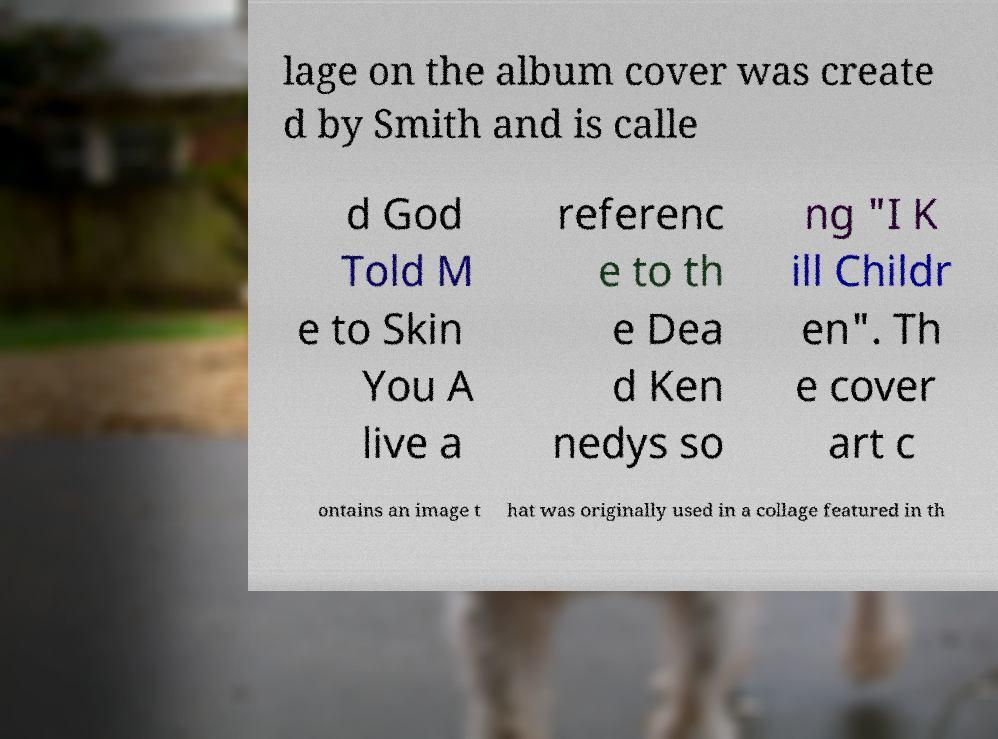Can you read and provide the text displayed in the image?This photo seems to have some interesting text. Can you extract and type it out for me? lage on the album cover was create d by Smith and is calle d God Told M e to Skin You A live a referenc e to th e Dea d Ken nedys so ng "I K ill Childr en". Th e cover art c ontains an image t hat was originally used in a collage featured in th 